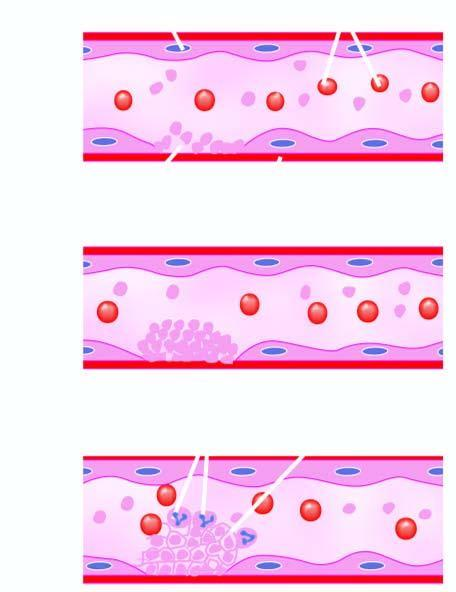s adp released which causes further aggregation of platelets following platelet release reaction?
Answer the question using a single word or phrase. Yes 